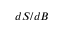Convert formula to latex. <formula><loc_0><loc_0><loc_500><loc_500>d S / d B</formula> 